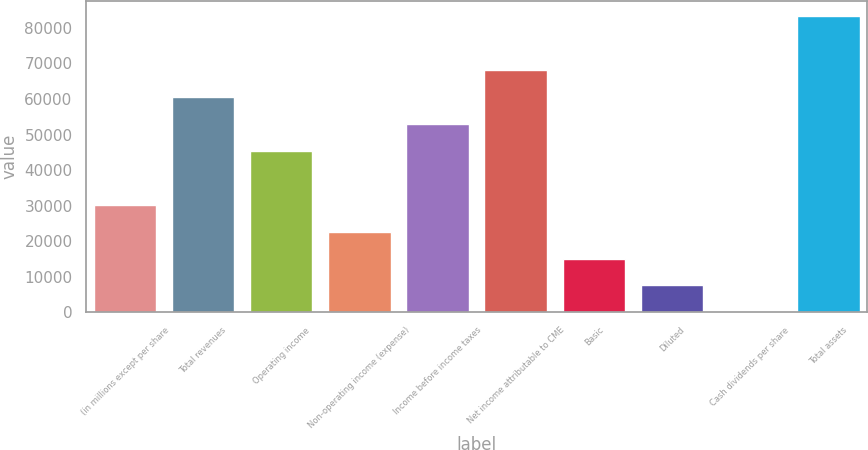Convert chart. <chart><loc_0><loc_0><loc_500><loc_500><bar_chart><fcel>(in millions except per share<fcel>Total revenues<fcel>Operating income<fcel>Non-operating income (expense)<fcel>Income before income taxes<fcel>Net income attributable to CME<fcel>Basic<fcel>Diluted<fcel>Cash dividends per share<fcel>Total assets<nl><fcel>30320.2<fcel>60634.2<fcel>45477.2<fcel>22741.7<fcel>53055.7<fcel>68212.7<fcel>15163.2<fcel>7584.65<fcel>6.14<fcel>83369.8<nl></chart> 